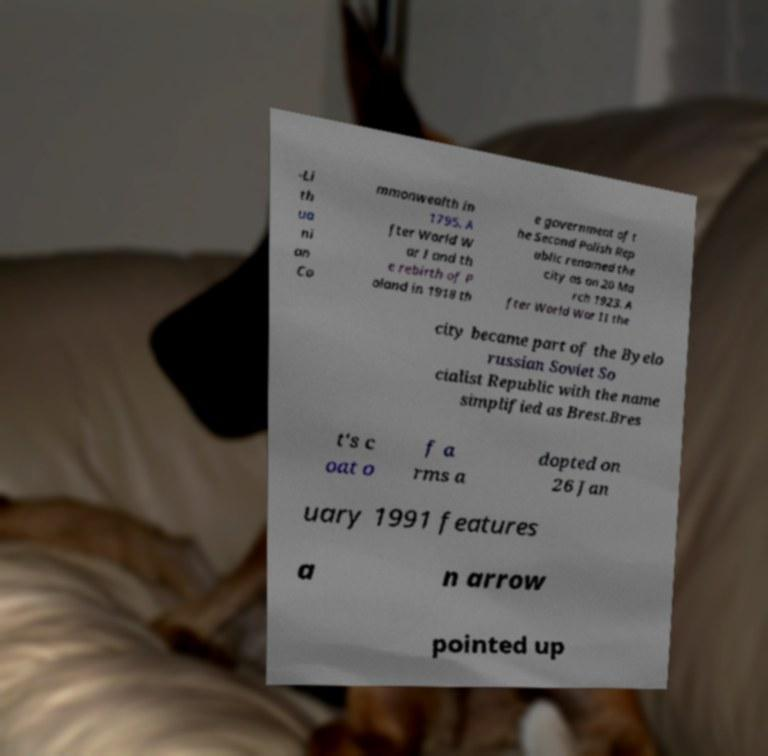I need the written content from this picture converted into text. Can you do that? -Li th ua ni an Co mmonwealth in 1795. A fter World W ar I and th e rebirth of P oland in 1918 th e government of t he Second Polish Rep ublic renamed the city as on 20 Ma rch 1923. A fter World War II the city became part of the Byelo russian Soviet So cialist Republic with the name simplified as Brest.Bres t's c oat o f a rms a dopted on 26 Jan uary 1991 features a n arrow pointed up 